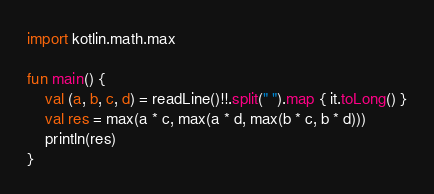Convert code to text. <code><loc_0><loc_0><loc_500><loc_500><_Kotlin_>import kotlin.math.max

fun main() {
    val (a, b, c, d) = readLine()!!.split(" ").map { it.toLong() }
    val res = max(a * c, max(a * d, max(b * c, b * d)))
    println(res)
}</code> 